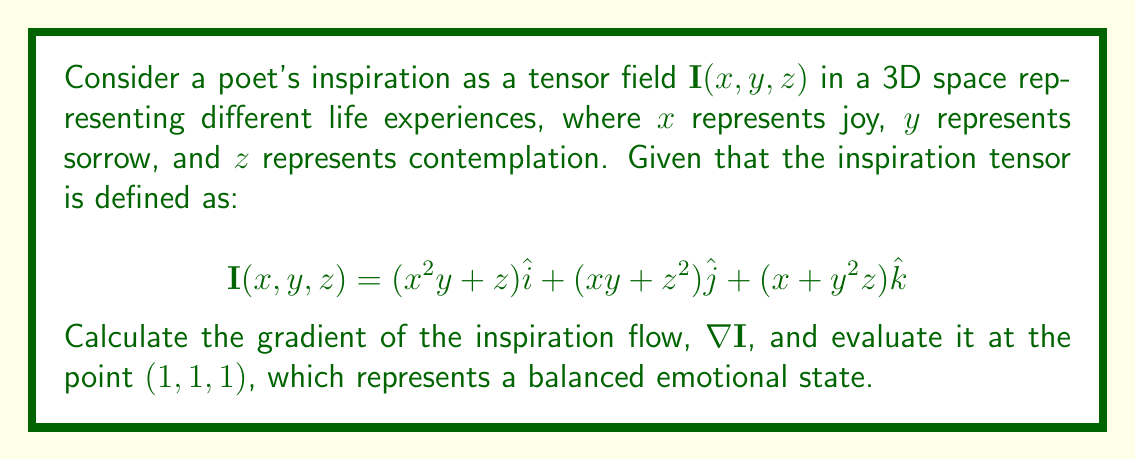Can you solve this math problem? To solve this problem, we need to follow these steps:

1) The gradient of a vector field $\mathbf{I}(x, y, z)$ is given by:

   $$\nabla \mathbf{I} = \begin{bmatrix}
   \frac{\partial I_x}{\partial x} & \frac{\partial I_x}{\partial y} & \frac{\partial I_x}{\partial z} \\
   \frac{\partial I_y}{\partial x} & \frac{\partial I_y}{\partial y} & \frac{\partial I_y}{\partial z} \\
   \frac{\partial I_z}{\partial x} & \frac{\partial I_z}{\partial y} & \frac{\partial I_z}{\partial z}
   \end{bmatrix}$$

2) Let's calculate each partial derivative:

   $\frac{\partial I_x}{\partial x} = 2xy$
   $\frac{\partial I_x}{\partial y} = x^2$
   $\frac{\partial I_x}{\partial z} = 1$

   $\frac{\partial I_y}{\partial x} = y$
   $\frac{\partial I_y}{\partial y} = x$
   $\frac{\partial I_y}{\partial z} = 2z$

   $\frac{\partial I_z}{\partial x} = 1$
   $\frac{\partial I_z}{\partial y} = 2yz$
   $\frac{\partial I_z}{\partial z} = y^2$

3) Now we can form the gradient matrix:

   $$\nabla \mathbf{I} = \begin{bmatrix}
   2xy & x^2 & 1 \\
   y & x & 2z \\
   1 & 2yz & y^2
   \end{bmatrix}$$

4) Evaluating at the point $(1, 1, 1)$:

   $$\nabla \mathbf{I}(1,1,1) = \begin{bmatrix}
   2(1)(1) & 1^2 & 1 \\
   1 & 1 & 2(1) \\
   1 & 2(1)(1) & 1^2
   \end{bmatrix} = \begin{bmatrix}
   2 & 1 & 1 \\
   1 & 1 & 2 \\
   1 & 2 & 1
   \end{bmatrix}$$
Answer: $$\nabla \mathbf{I}(1,1,1) = \begin{bmatrix}
2 & 1 & 1 \\
1 & 1 & 2 \\
1 & 2 & 1
\end{bmatrix}$$ 